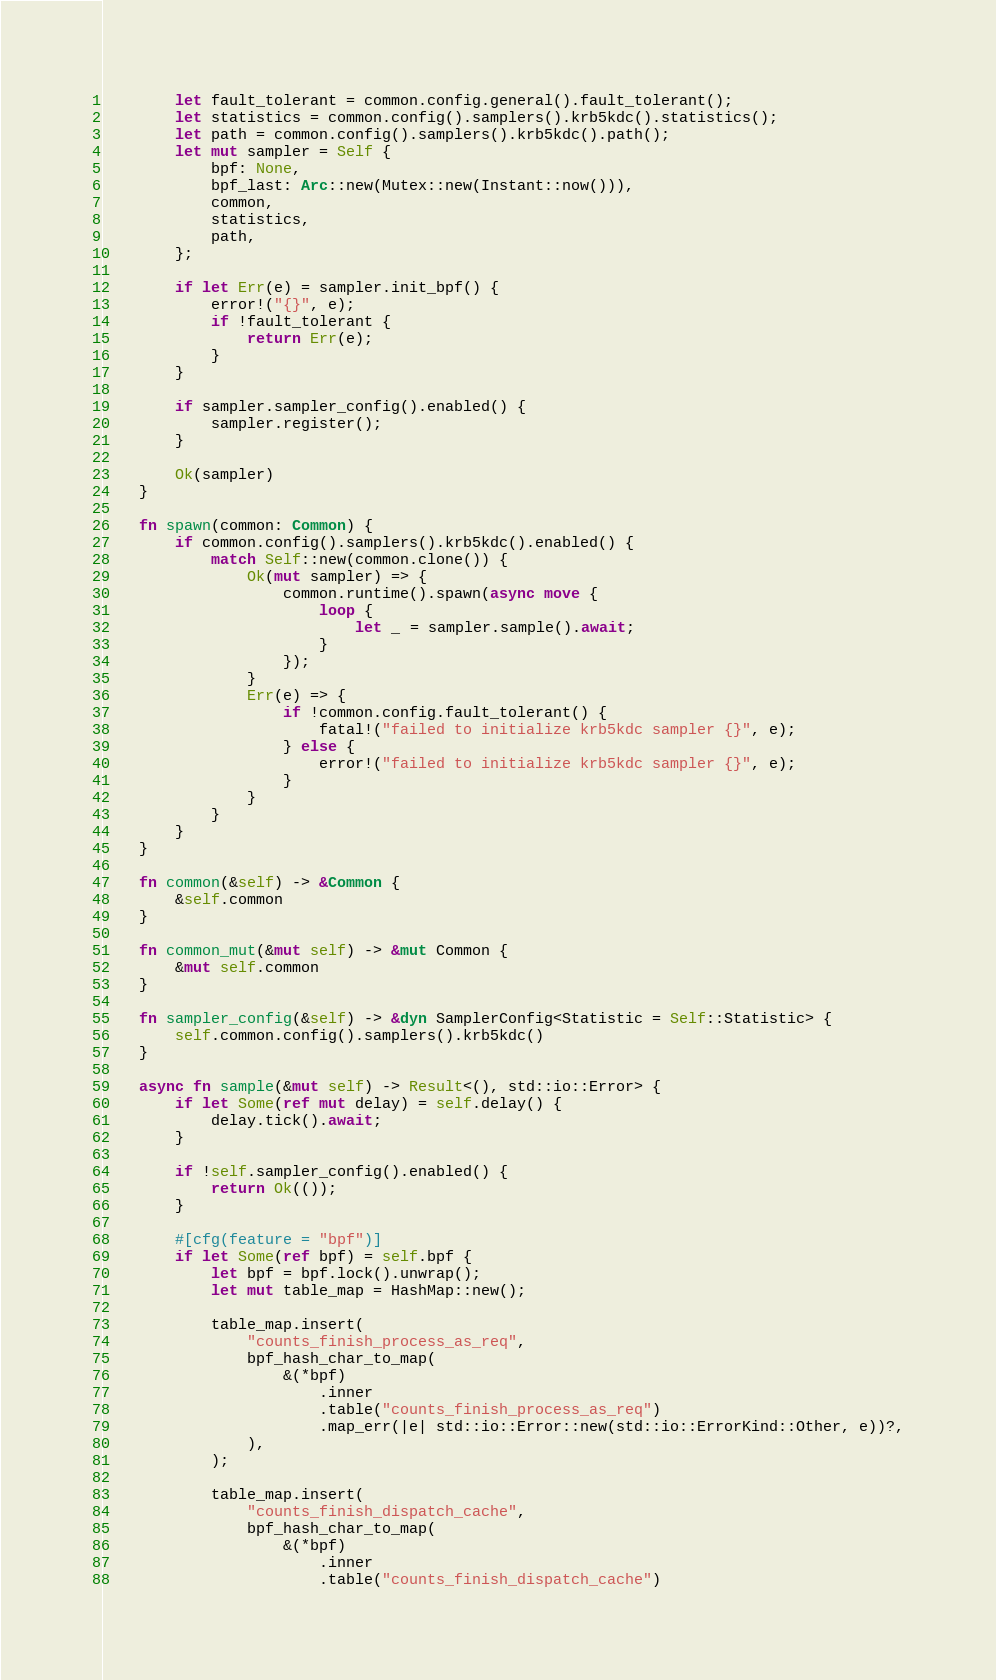Convert code to text. <code><loc_0><loc_0><loc_500><loc_500><_Rust_>        let fault_tolerant = common.config.general().fault_tolerant();
        let statistics = common.config().samplers().krb5kdc().statistics();
        let path = common.config().samplers().krb5kdc().path();
        let mut sampler = Self {
            bpf: None,
            bpf_last: Arc::new(Mutex::new(Instant::now())),
            common,
            statistics,
            path,
        };

        if let Err(e) = sampler.init_bpf() {
            error!("{}", e);
            if !fault_tolerant {
                return Err(e);
            }
        }

        if sampler.sampler_config().enabled() {
            sampler.register();
        }

        Ok(sampler)
    }

    fn spawn(common: Common) {
        if common.config().samplers().krb5kdc().enabled() {
            match Self::new(common.clone()) {
                Ok(mut sampler) => {
                    common.runtime().spawn(async move {
                        loop {
                            let _ = sampler.sample().await;
                        }
                    });
                }
                Err(e) => {
                    if !common.config.fault_tolerant() {
                        fatal!("failed to initialize krb5kdc sampler {}", e);
                    } else {
                        error!("failed to initialize krb5kdc sampler {}", e);
                    }
                }
            }
        }
    }

    fn common(&self) -> &Common {
        &self.common
    }

    fn common_mut(&mut self) -> &mut Common {
        &mut self.common
    }

    fn sampler_config(&self) -> &dyn SamplerConfig<Statistic = Self::Statistic> {
        self.common.config().samplers().krb5kdc()
    }

    async fn sample(&mut self) -> Result<(), std::io::Error> {
        if let Some(ref mut delay) = self.delay() {
            delay.tick().await;
        }

        if !self.sampler_config().enabled() {
            return Ok(());
        }

        #[cfg(feature = "bpf")]
        if let Some(ref bpf) = self.bpf {
            let bpf = bpf.lock().unwrap();
            let mut table_map = HashMap::new();

            table_map.insert(
                "counts_finish_process_as_req",
                bpf_hash_char_to_map(
                    &(*bpf)
                        .inner
                        .table("counts_finish_process_as_req")
                        .map_err(|e| std::io::Error::new(std::io::ErrorKind::Other, e))?,
                ),
            );

            table_map.insert(
                "counts_finish_dispatch_cache",
                bpf_hash_char_to_map(
                    &(*bpf)
                        .inner
                        .table("counts_finish_dispatch_cache")</code> 